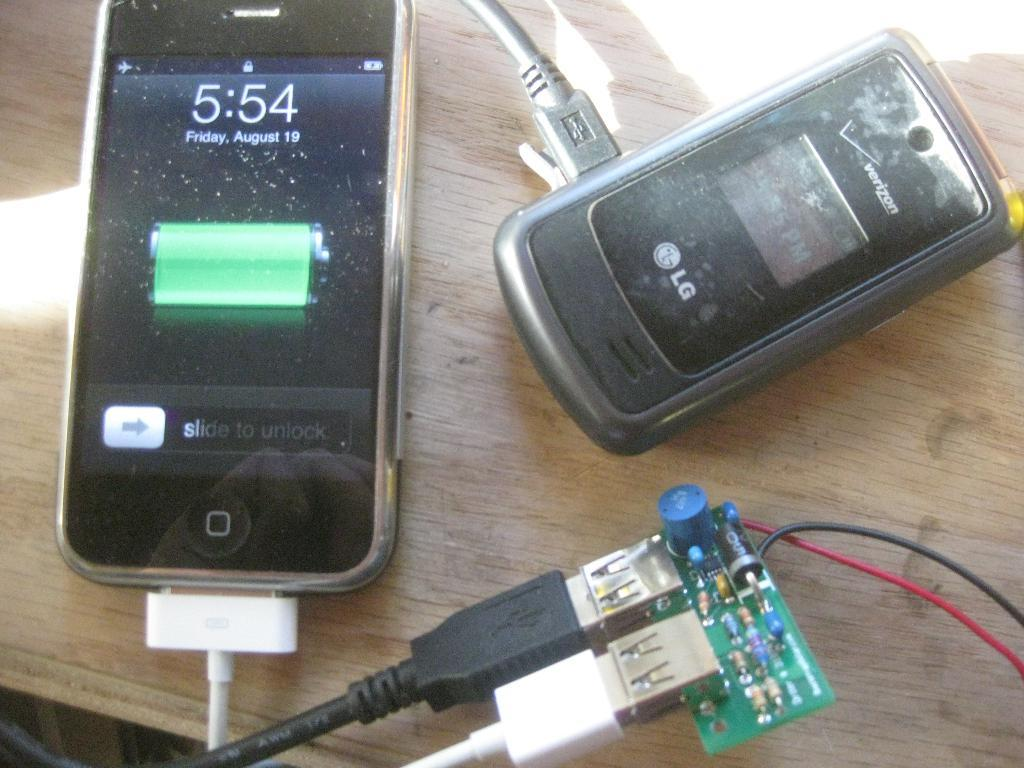<image>
Provide a brief description of the given image. An iPhone and an LG Verizon phone are plugged in and the time is 5:54. 